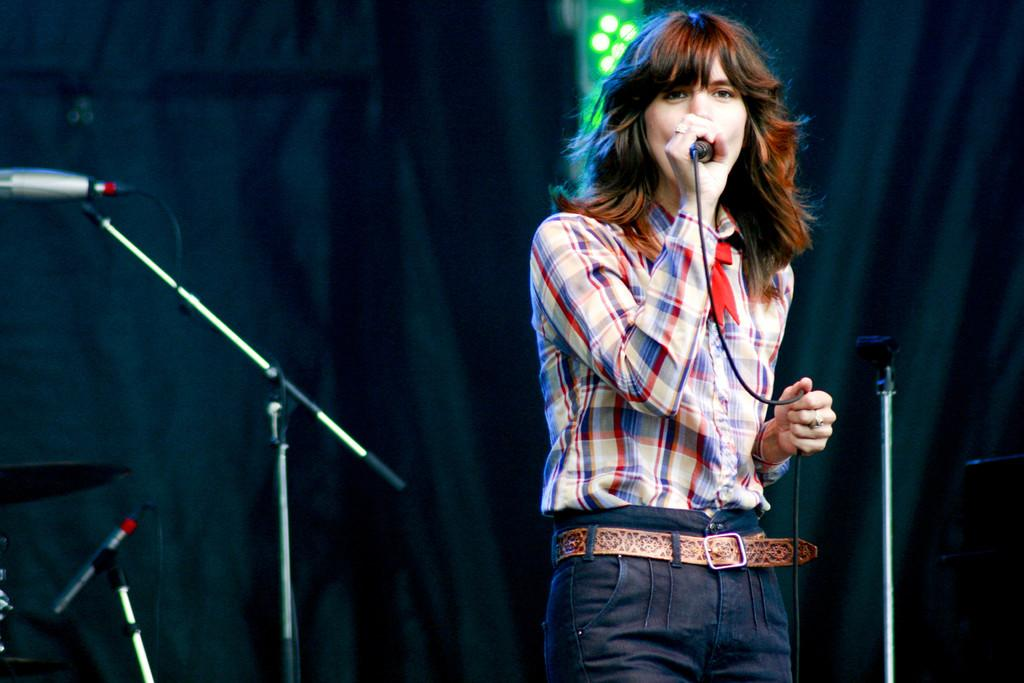Who is the main subject in the image? There is a woman in the image. What is the woman holding in the image? The woman is holding a microphone. Where is the woman located in the image? The woman is on a stage. How many microphones can be seen on the stage? There are multiple microphones on the stage. What type of deer can be seen in the image? There are no deer present in the image. How does the taste of the microphone affect the woman's performance? The microphone does not have a taste, so it cannot affect the woman's performance in that way. 